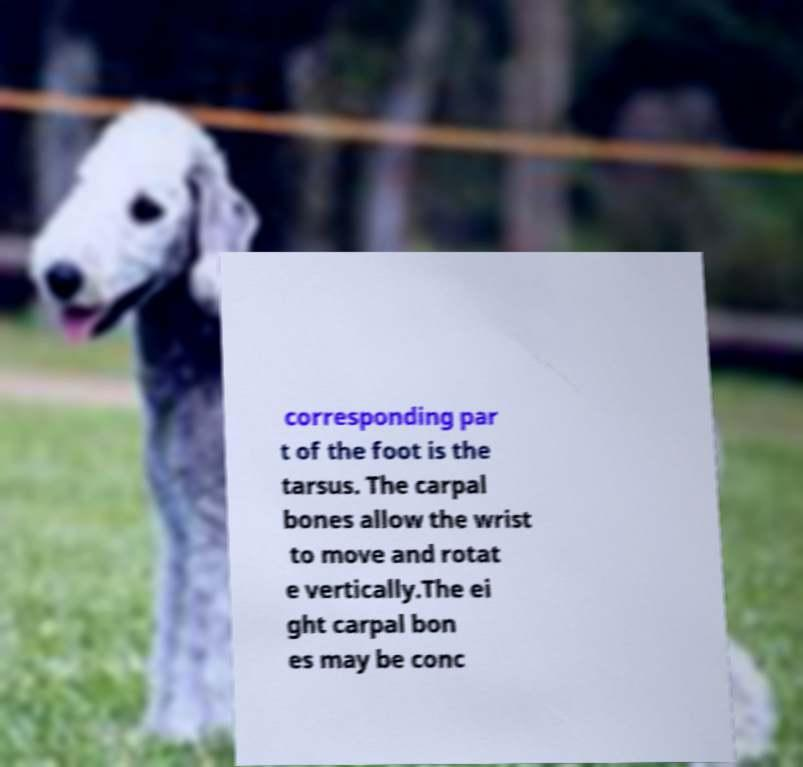Could you assist in decoding the text presented in this image and type it out clearly? corresponding par t of the foot is the tarsus. The carpal bones allow the wrist to move and rotat e vertically.The ei ght carpal bon es may be conc 